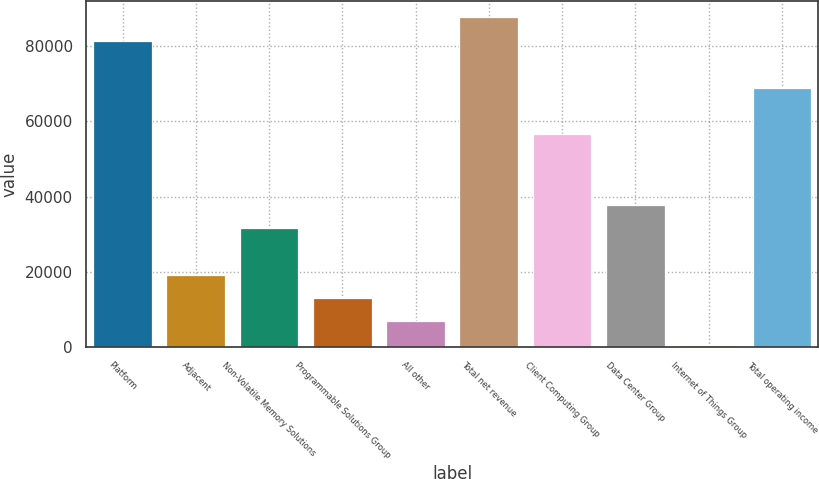Convert chart. <chart><loc_0><loc_0><loc_500><loc_500><bar_chart><fcel>Platform<fcel>Adjacent<fcel>Non-Volatile Memory Solutions<fcel>Programmable Solutions Group<fcel>All other<fcel>Total net revenue<fcel>Client Computing Group<fcel>Data Center Group<fcel>Internet of Things Group<fcel>Total operating income<nl><fcel>81394.3<fcel>19283.3<fcel>31705.5<fcel>13072.2<fcel>6861.1<fcel>87605.4<fcel>56549.9<fcel>37916.6<fcel>650<fcel>68972.1<nl></chart> 